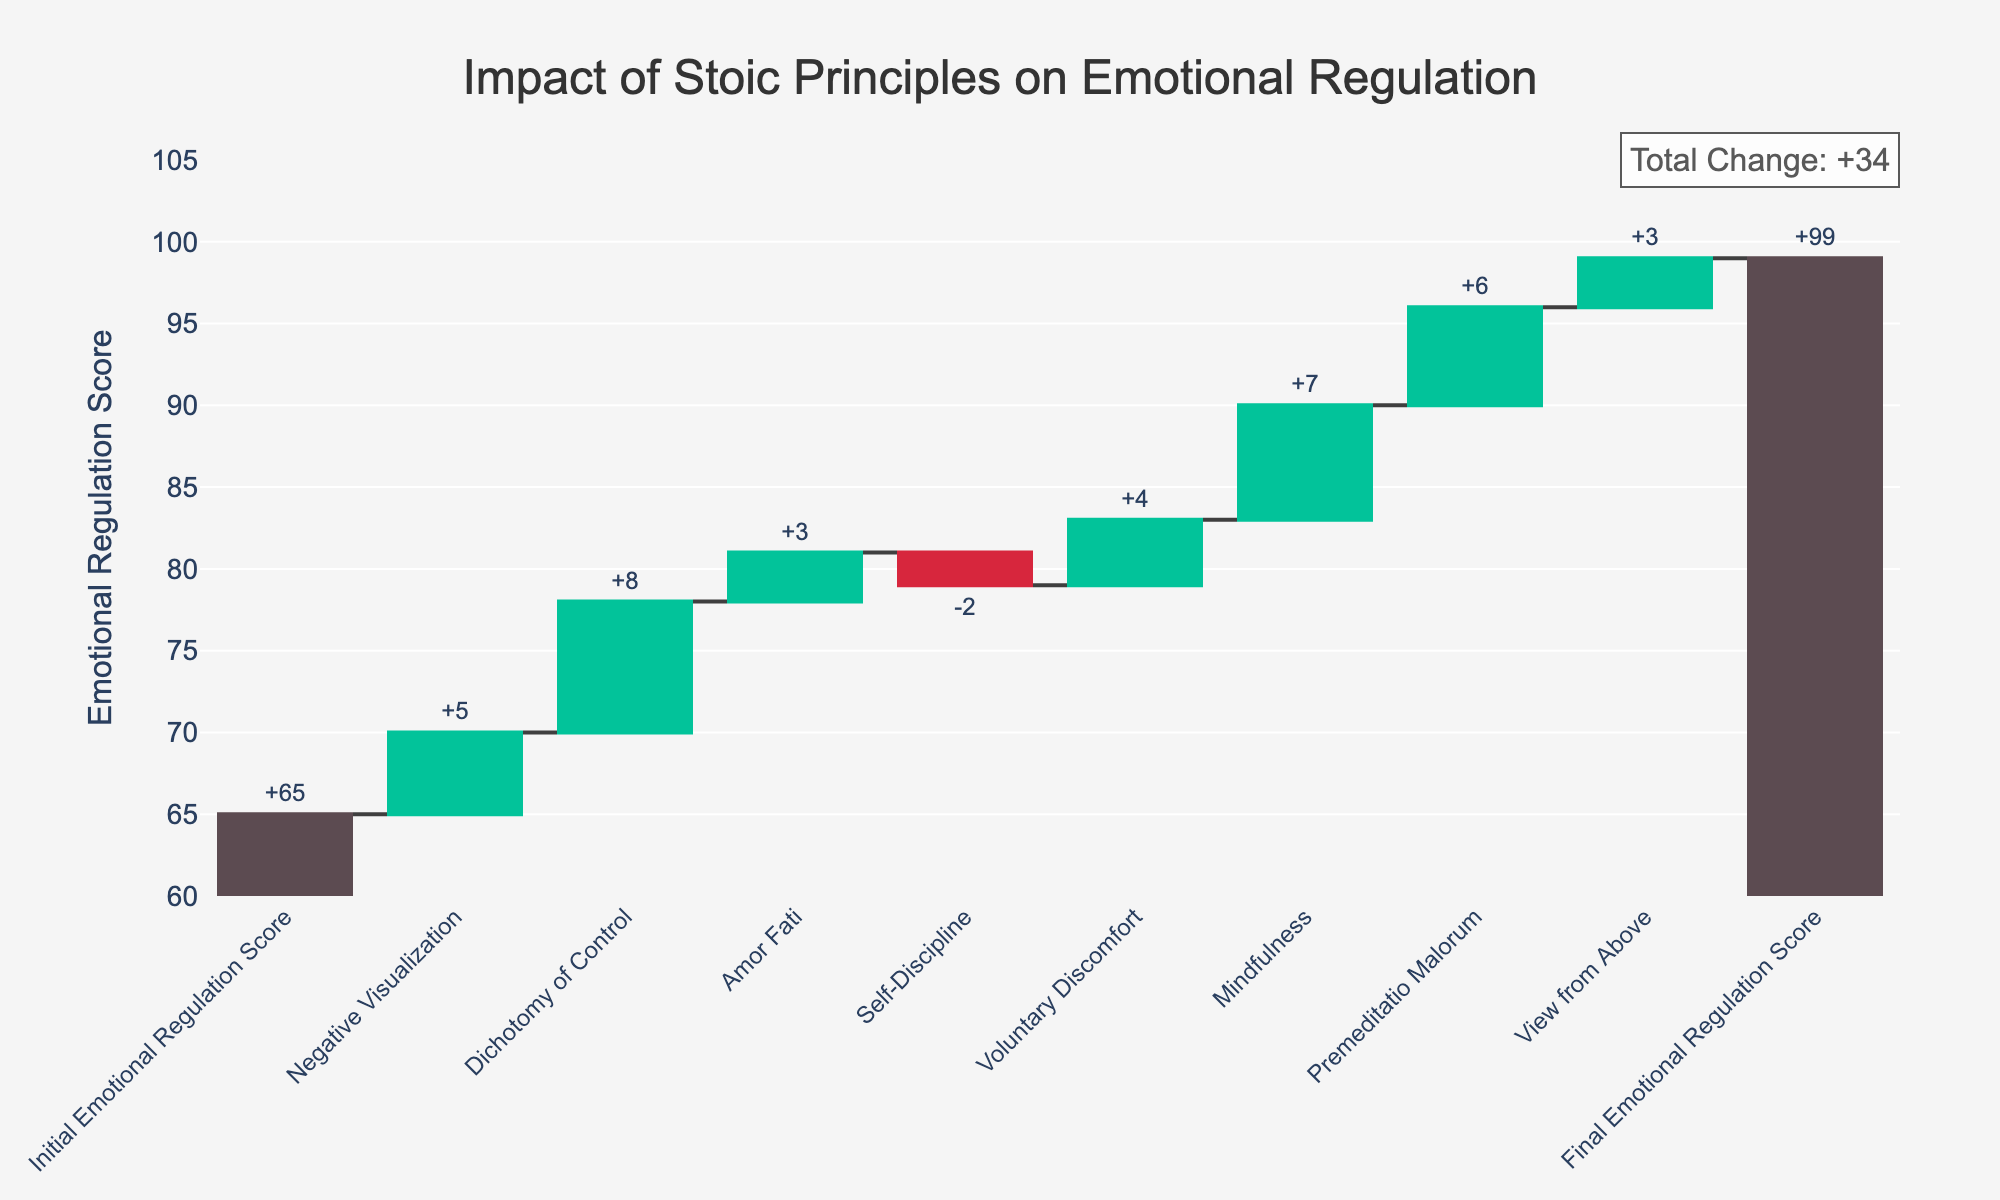What is the initial emotional regulation score? The initial emotional regulation score is indicated by the first bar in the waterfall chart labeled "Initial Emotional Regulation Score".
Answer: 65 Which Stoic principle contributed the most to the improvement in emotional regulation scores? The Stoic principle with the largest positive value on the waterfall chart is "Dichotomy of Control" with a value of 8.
Answer: Dichotomy of Control How many Stoic principles showed a decrease in emotional regulation scores? Looking at the principles and their corresponding values, "Self-Discipline" has a negative value of -2, indicating a decrease.
Answer: 1 What is the final emotional regulation score? The final emotional regulation score is indicated by the last bar labeled "Final Emotional Regulation Score".
Answer: 99 What is the combined contribution of "Negative Visualization" and "Mindfulness" to the emotional regulation score? The values for "Negative Visualization" and "Mindfulness" on the waterfall chart are 5 and 7, respectively. Adding these together gives 5 + 7.
Answer: 12 Did "Voluntary Discomfort" have a greater impact than "Amor Fati"? The impact of "Voluntary Discomfort" is 4 and the impact of "Amor Fati" is 3. Comparing these values, 4 is greater than 3.
Answer: Yes How much did "Negative Visualization" improve the emotional regulation score? The "Negative Visualization" bar shows a positive value of 5 on the waterfall chart.
Answer: 5 What was the total change in the emotional regulation score? The total change is noted in the annotation at the top of the chart as the sum of all incremental changes except the initial and final scores. The annotation states the total change explicitly.
Answer: +34 Which principle had the smallest positive impact on emotional regulation? Among the positive values indicated on the chart, "Amor Fati" and "View from Above" both have the smallest positive impact of 3.
Answer: Amor Fati or View from Above How many Stoic principles are represented on the chart? Counting the distinct Stoic principles listed between the initial and final scores on the x-axis gives a total of 8 principles.
Answer: 8 